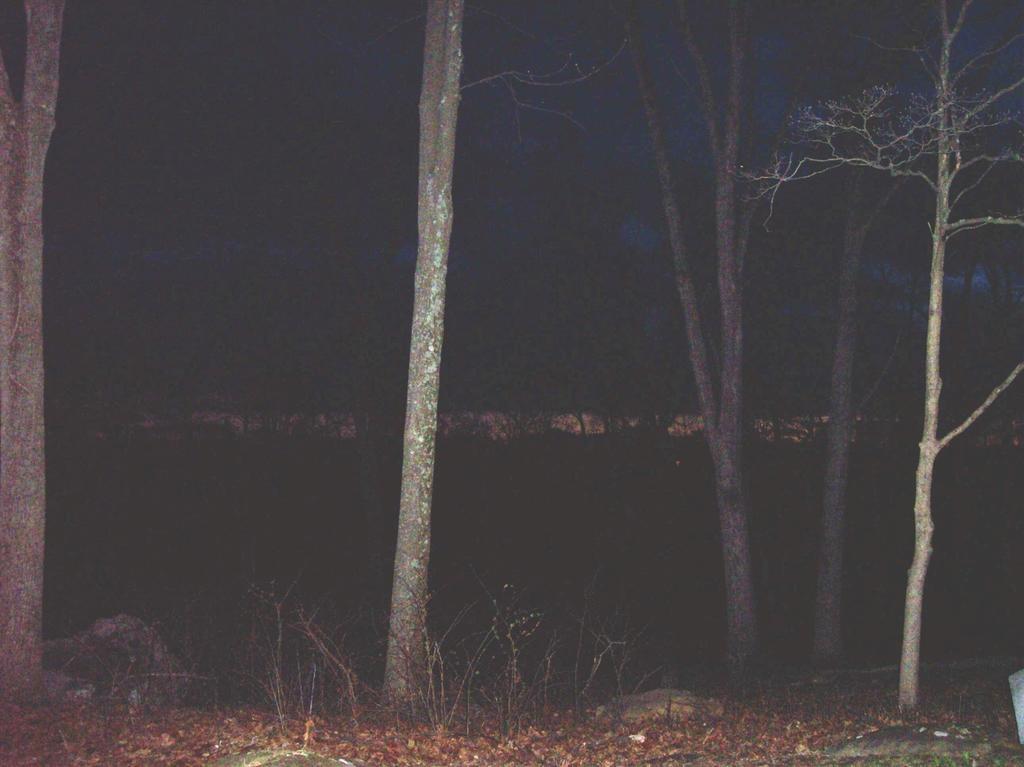In one or two sentences, can you explain what this image depicts? In this picture we can see the night view of a place with many trees and grass on the ground. 